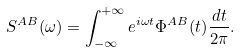<formula> <loc_0><loc_0><loc_500><loc_500>S ^ { A B } ( \omega ) = \int _ { - \infty } ^ { + \infty } e ^ { i \omega t } \Phi ^ { A B } ( t ) \frac { d t } { 2 \pi } .</formula> 